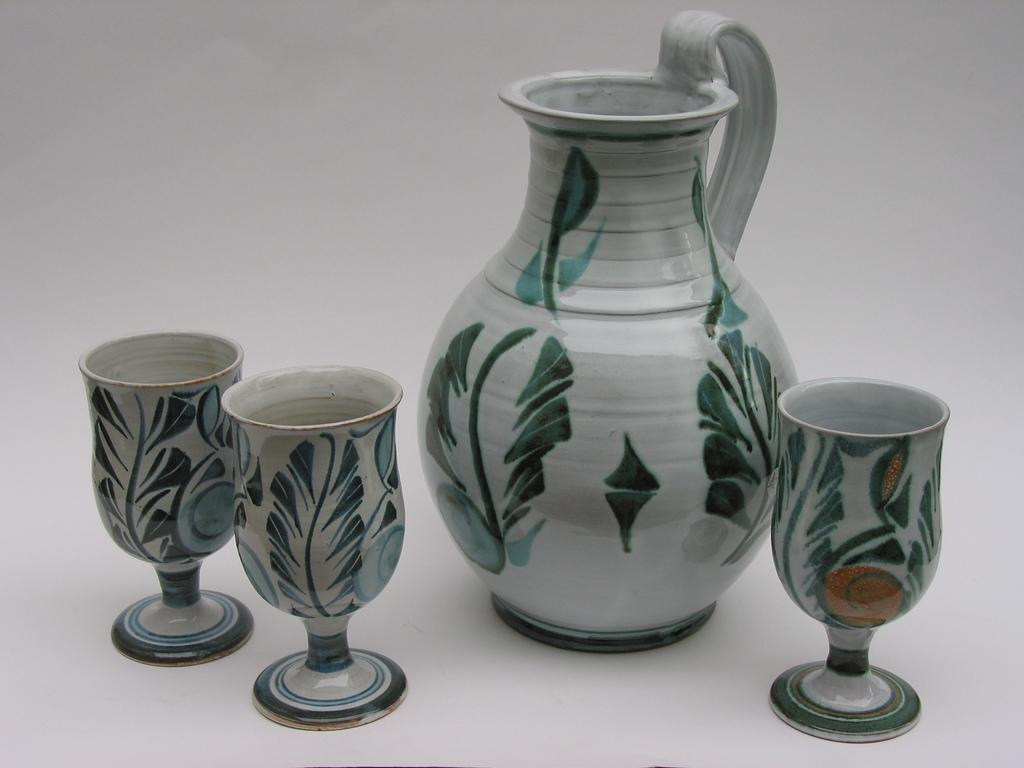What is present in the image that can hold liquids? There is a jar and glasses in the image. What can be observed about the glasses in the image? The glasses have designs on them. What type of trouble can be seen in the image? There is no indication of trouble in the image; it features a jar and glasses with designs. How does the control panel look like in the image? There is no control panel present in the image. 